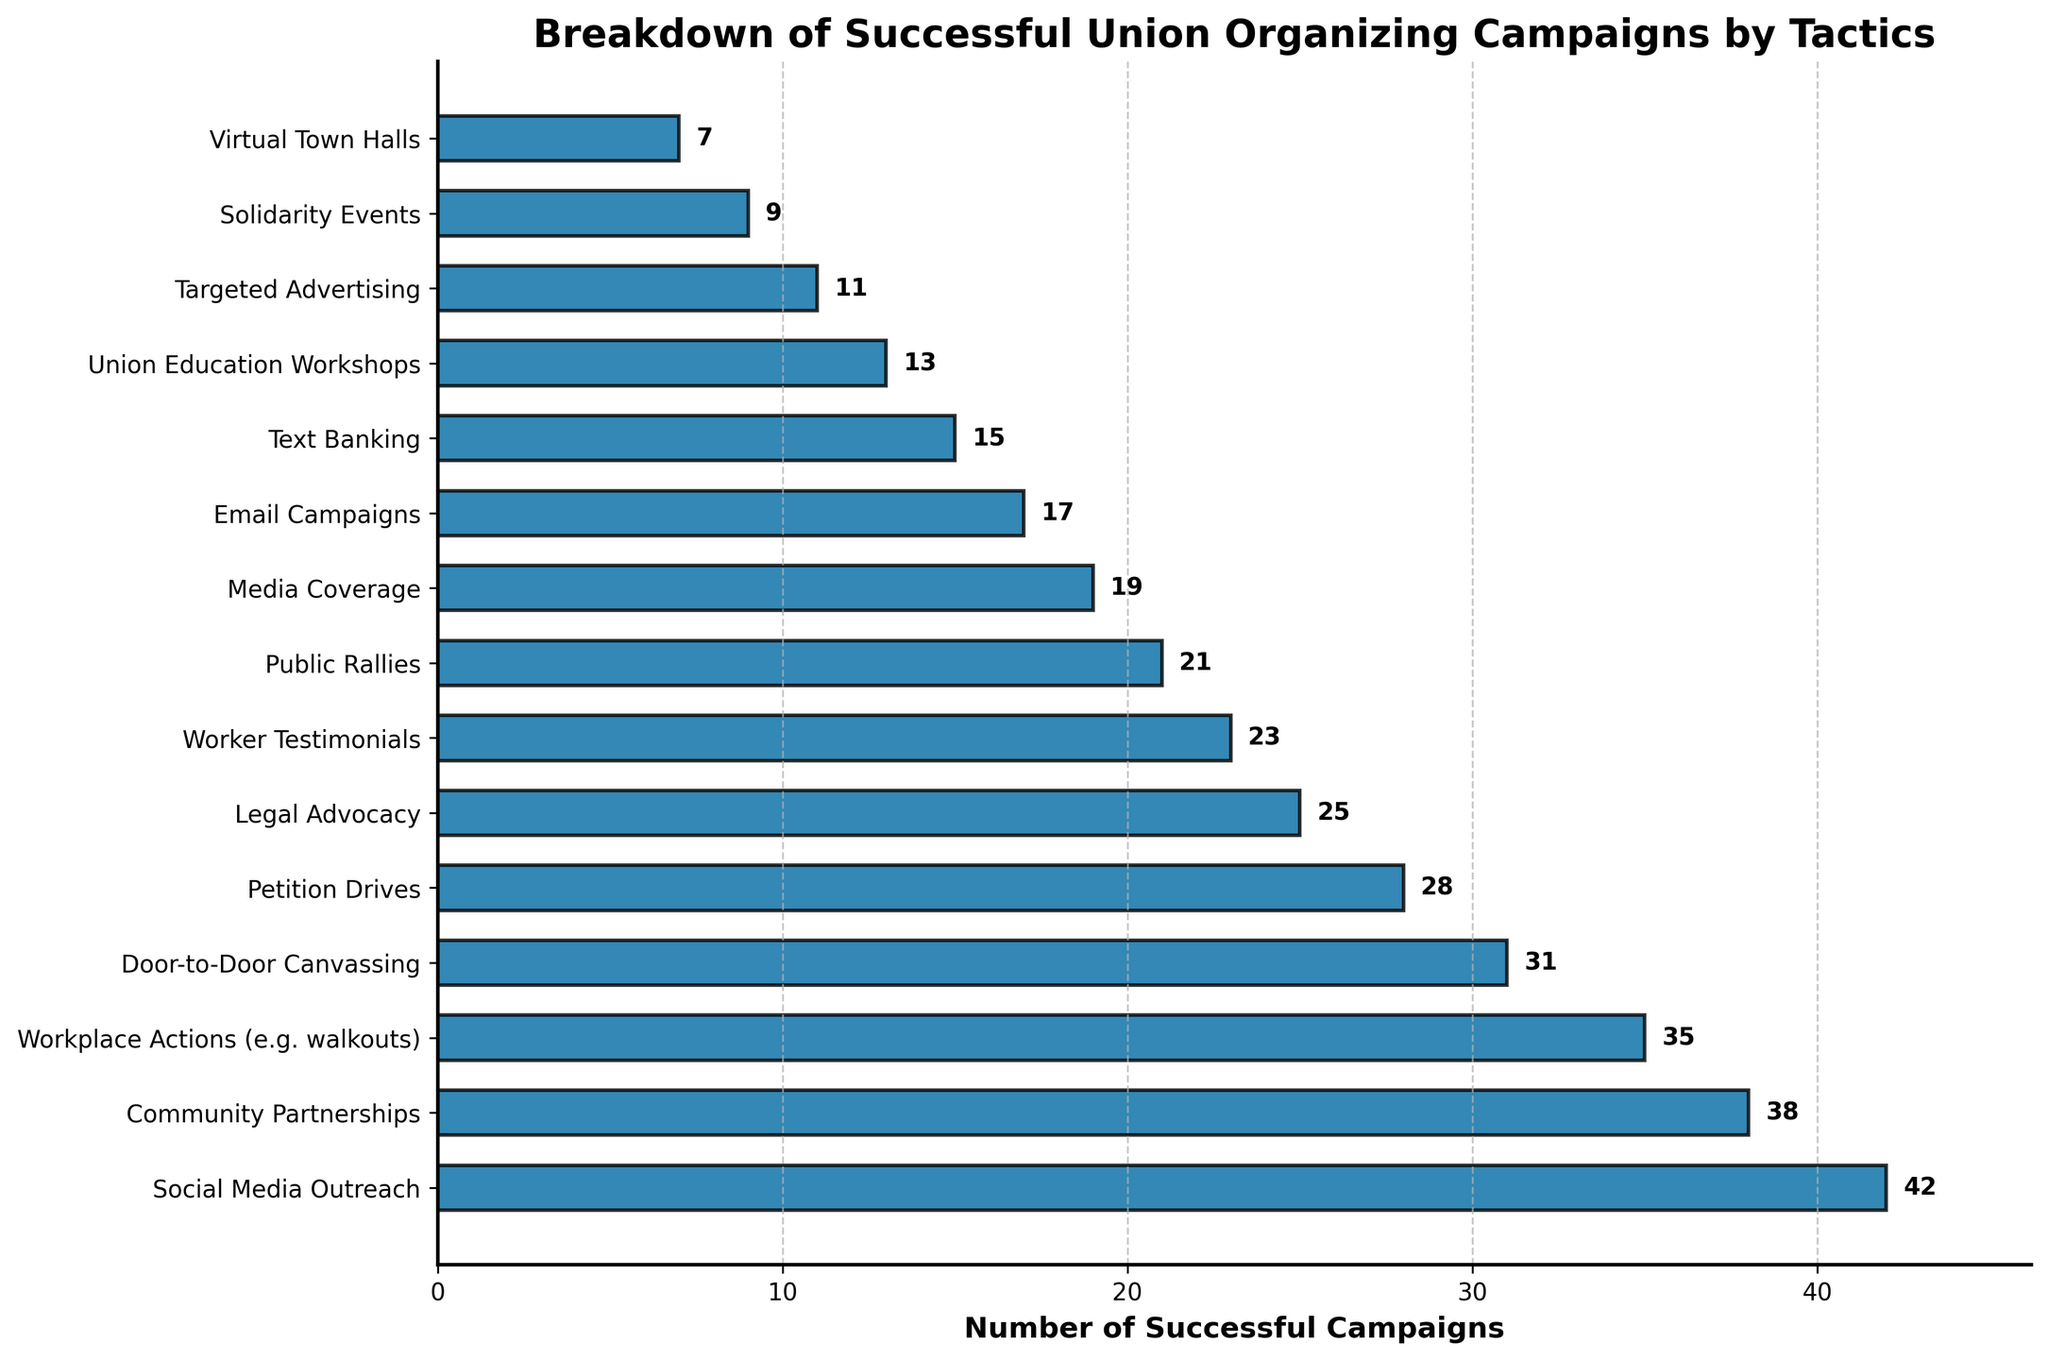Which tactic had the highest number of successful campaigns? Look at the bar corresponding to 'Social Media Outreach' which is the longest bar and check its value of 42.
Answer: Social Media Outreach Which two tactics had the closest number of successful campaigns? Compare the values of all tactics and find that 'Workplace Actions' and 'Community Partnerships' are closest with values of 35 and 38 respectively.
Answer: Workplace Actions, Community Partnerships How many more successful campaigns were achieved through Social Media Outreach compared to Text Banking? Subtract the number of successful campaigns for Text Banking (15) from that for Social Media Outreach (42). 42 - 15 = 27
Answer: 27 What is the total number of successful campaigns for Workplace Actions, Petition Drives, and Legal Advocacy combined? Add the number of successful campaigns for 'Workplace Actions' (35), 'Petition Drives' (28), and 'Legal Advocacy' (25). 35 + 28 + 25 = 88
Answer: 88 How many tactics had fewer than 20 successful campaigns? Identify the bars with values less than 20: Media Coverage (19), Email Campaigns (17), Text Banking (15), Union Education Workshops (13), Targeted Advertising (11), Solidarity Events (9), Virtual Town Halls (7). Count these bars.
Answer: 7 Which tactic had the second-highest number of successful campaigns? Observe and compare the lengths of the bars to find that 'Community Partnerships' with 38 successful campaigns is the second-longest.
Answer: Community Partnerships What is the total number of successful campaigns for the tactics that had at least 30 successful campaigns? Add the successful campaigns for 'Social Media Outreach' (42), 'Community Partnerships' (38), 'Workplace Actions' (35), and 'Door-to-Door Canvassing' (31). 42 + 38 + 35 + 31 = 146
Answer: 146 How many more successful campaigns were achieved through Petition Drives compared to Virtual Town Halls? Subtract the number of successful campaigns for Virtual Town Halls (7) from Petition Drives (28). 28 - 7 = 21
Answer: 21 Which tactics have values that are exactly divisible by 7? Examine each value to find numbers exactly divisible by 7: Social Media Outreach (42), Workplace Actions (35), Petition Drives (28), and Door-to-Door Canvassing (31 is not exactly divisible).
Answer: Social Media Outreach, Workplace Actions, Petition Drives What is the average number of successful campaigns for the top three tactics? Add the number of successful campaigns for the top three tactics 'Social Media Outreach' (42), 'Community Partnerships' (38), and 'Workplace Actions' (35), then divide by 3. (42 + 38 + 35) / 3 = 115 / 3 = 38.33
Answer: 38.33 